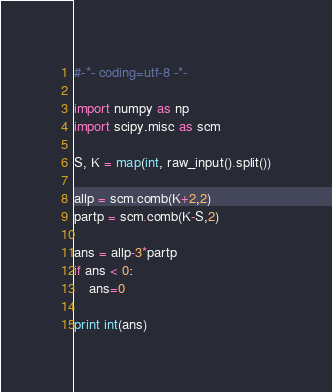<code> <loc_0><loc_0><loc_500><loc_500><_Python_>#-*- coding=utf-8 -*-

import numpy as np
import scipy.misc as scm

S, K = map(int, raw_input().split())

allp = scm.comb(K+2,2)
partp = scm.comb(K-S,2)

ans = allp-3*partp
if ans < 0:
    ans=0

print int(ans)
</code> 